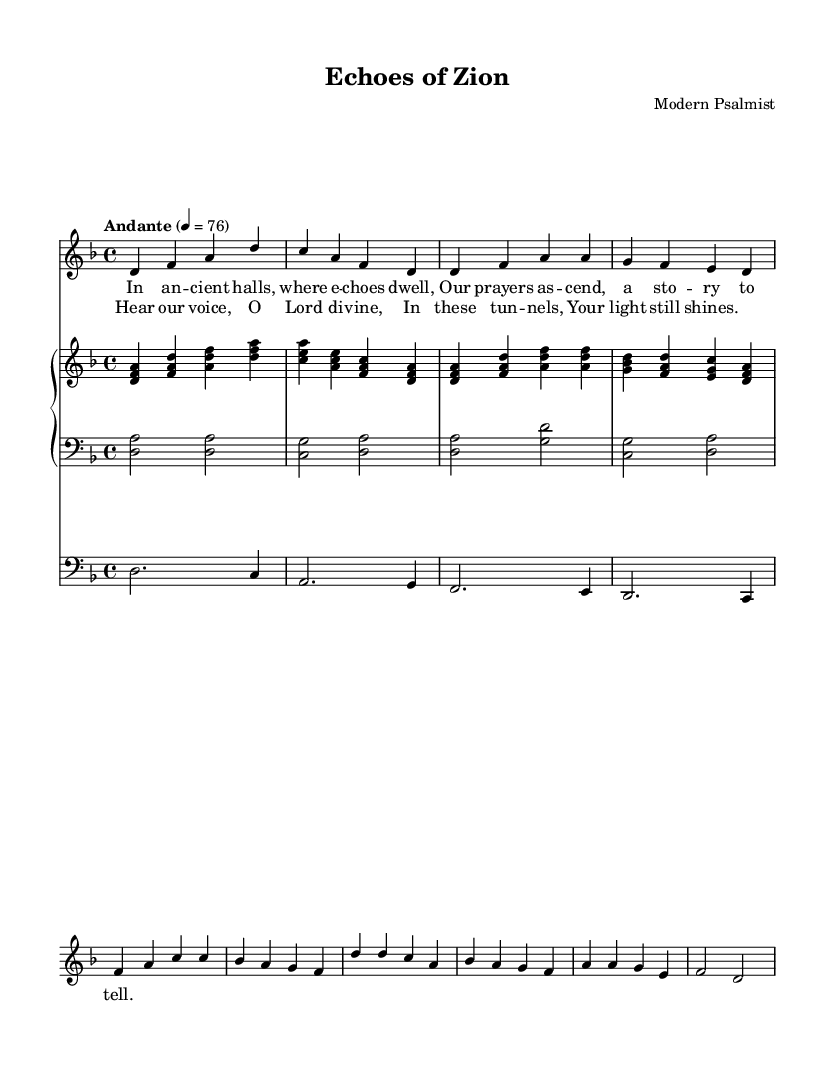What is the key signature of this music? The key signature is D minor, which has one flat (B flat). This can be identified in the key signature section at the beginning of the sheet music, specifically placed at the start of the staff.
Answer: D minor What is the time signature of this piece? The time signature is 4/4, indicating that there are four beats in each measure and a quarter note receives one beat. This can be found at the beginning of the sheet music, just after the key signature.
Answer: 4/4 What is the tempo marking for this music? The tempo marking is "Andante," indicating a moderately slow tempo. The tempo is specified at the beginning of the score, indicating how fast or slow the music should be played.
Answer: Andante How many notes are in the vocal chorus line? The vocal chorus line contains eight notes, which can be counted by analyzing the chorus part of the provided score under the lyrics section, observing the respective note values.
Answer: Eight What is the structure of the lyrics in this piece? The lyrics are structured into verses and a chorus. This can be understood by checking the labeled sections, where the verse lyrics are distinct from the chorus lyrics, creating a clear format in the sheet music.
Answer: Verse and chorus Which instruments are included in this score? The instruments included are voice, piano, and cello. This can be determined by examining the staff labels and the various instrumental parts indicated at the beginning of the score.
Answer: Voice, piano, and cello What is the final note of the vocal line? The final note of the vocal line is D. This can be identified by looking at the last note in the chorus line of the vocal part, noting its pitch location on the staff.
Answer: D 